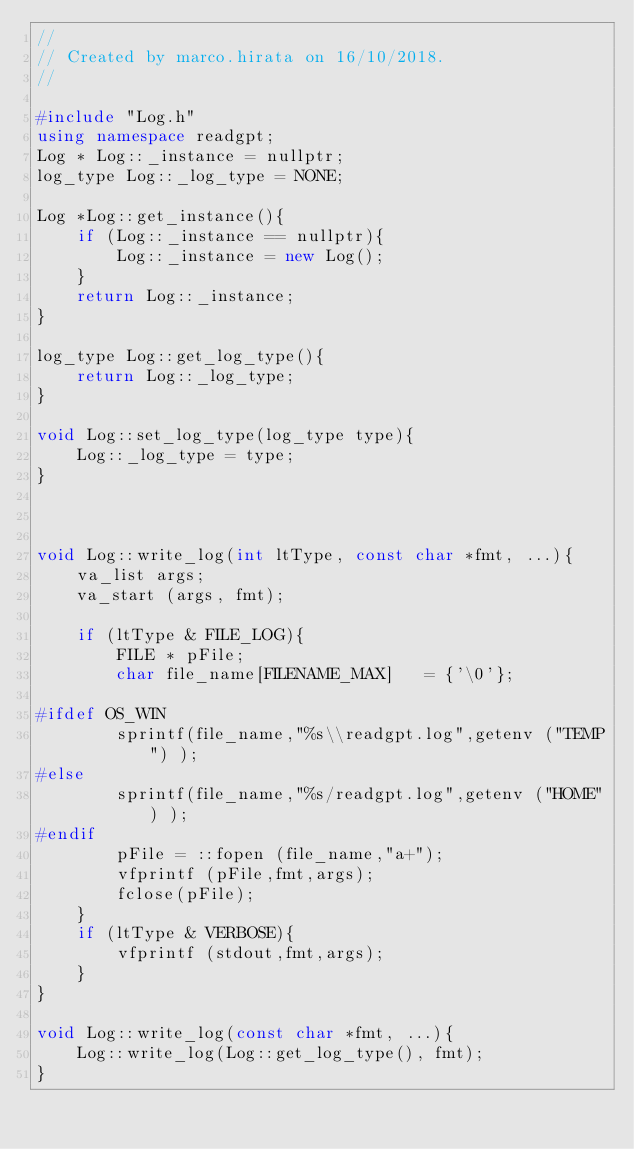<code> <loc_0><loc_0><loc_500><loc_500><_C++_>//
// Created by marco.hirata on 16/10/2018.
//

#include "Log.h"
using namespace readgpt;
Log * Log::_instance = nullptr;
log_type Log::_log_type = NONE;

Log *Log::get_instance(){
    if (Log::_instance == nullptr){
        Log::_instance = new Log();
    }
    return Log::_instance;
}

log_type Log::get_log_type(){
    return Log::_log_type;
}

void Log::set_log_type(log_type type){
    Log::_log_type = type;
}



void Log::write_log(int ltType, const char *fmt, ...){
    va_list args;
    va_start (args, fmt);

    if (ltType & FILE_LOG){
        FILE * pFile;
        char file_name[FILENAME_MAX]   = {'\0'};

#ifdef OS_WIN
        sprintf(file_name,"%s\\readgpt.log",getenv ("TEMP") );
#else
        sprintf(file_name,"%s/readgpt.log",getenv ("HOME") );
#endif
        pFile = ::fopen (file_name,"a+");
        vfprintf (pFile,fmt,args);
        fclose(pFile);
    }
    if (ltType & VERBOSE){
        vfprintf (stdout,fmt,args);
    }
}

void Log::write_log(const char *fmt, ...){
    Log::write_log(Log::get_log_type(), fmt);
}

</code> 